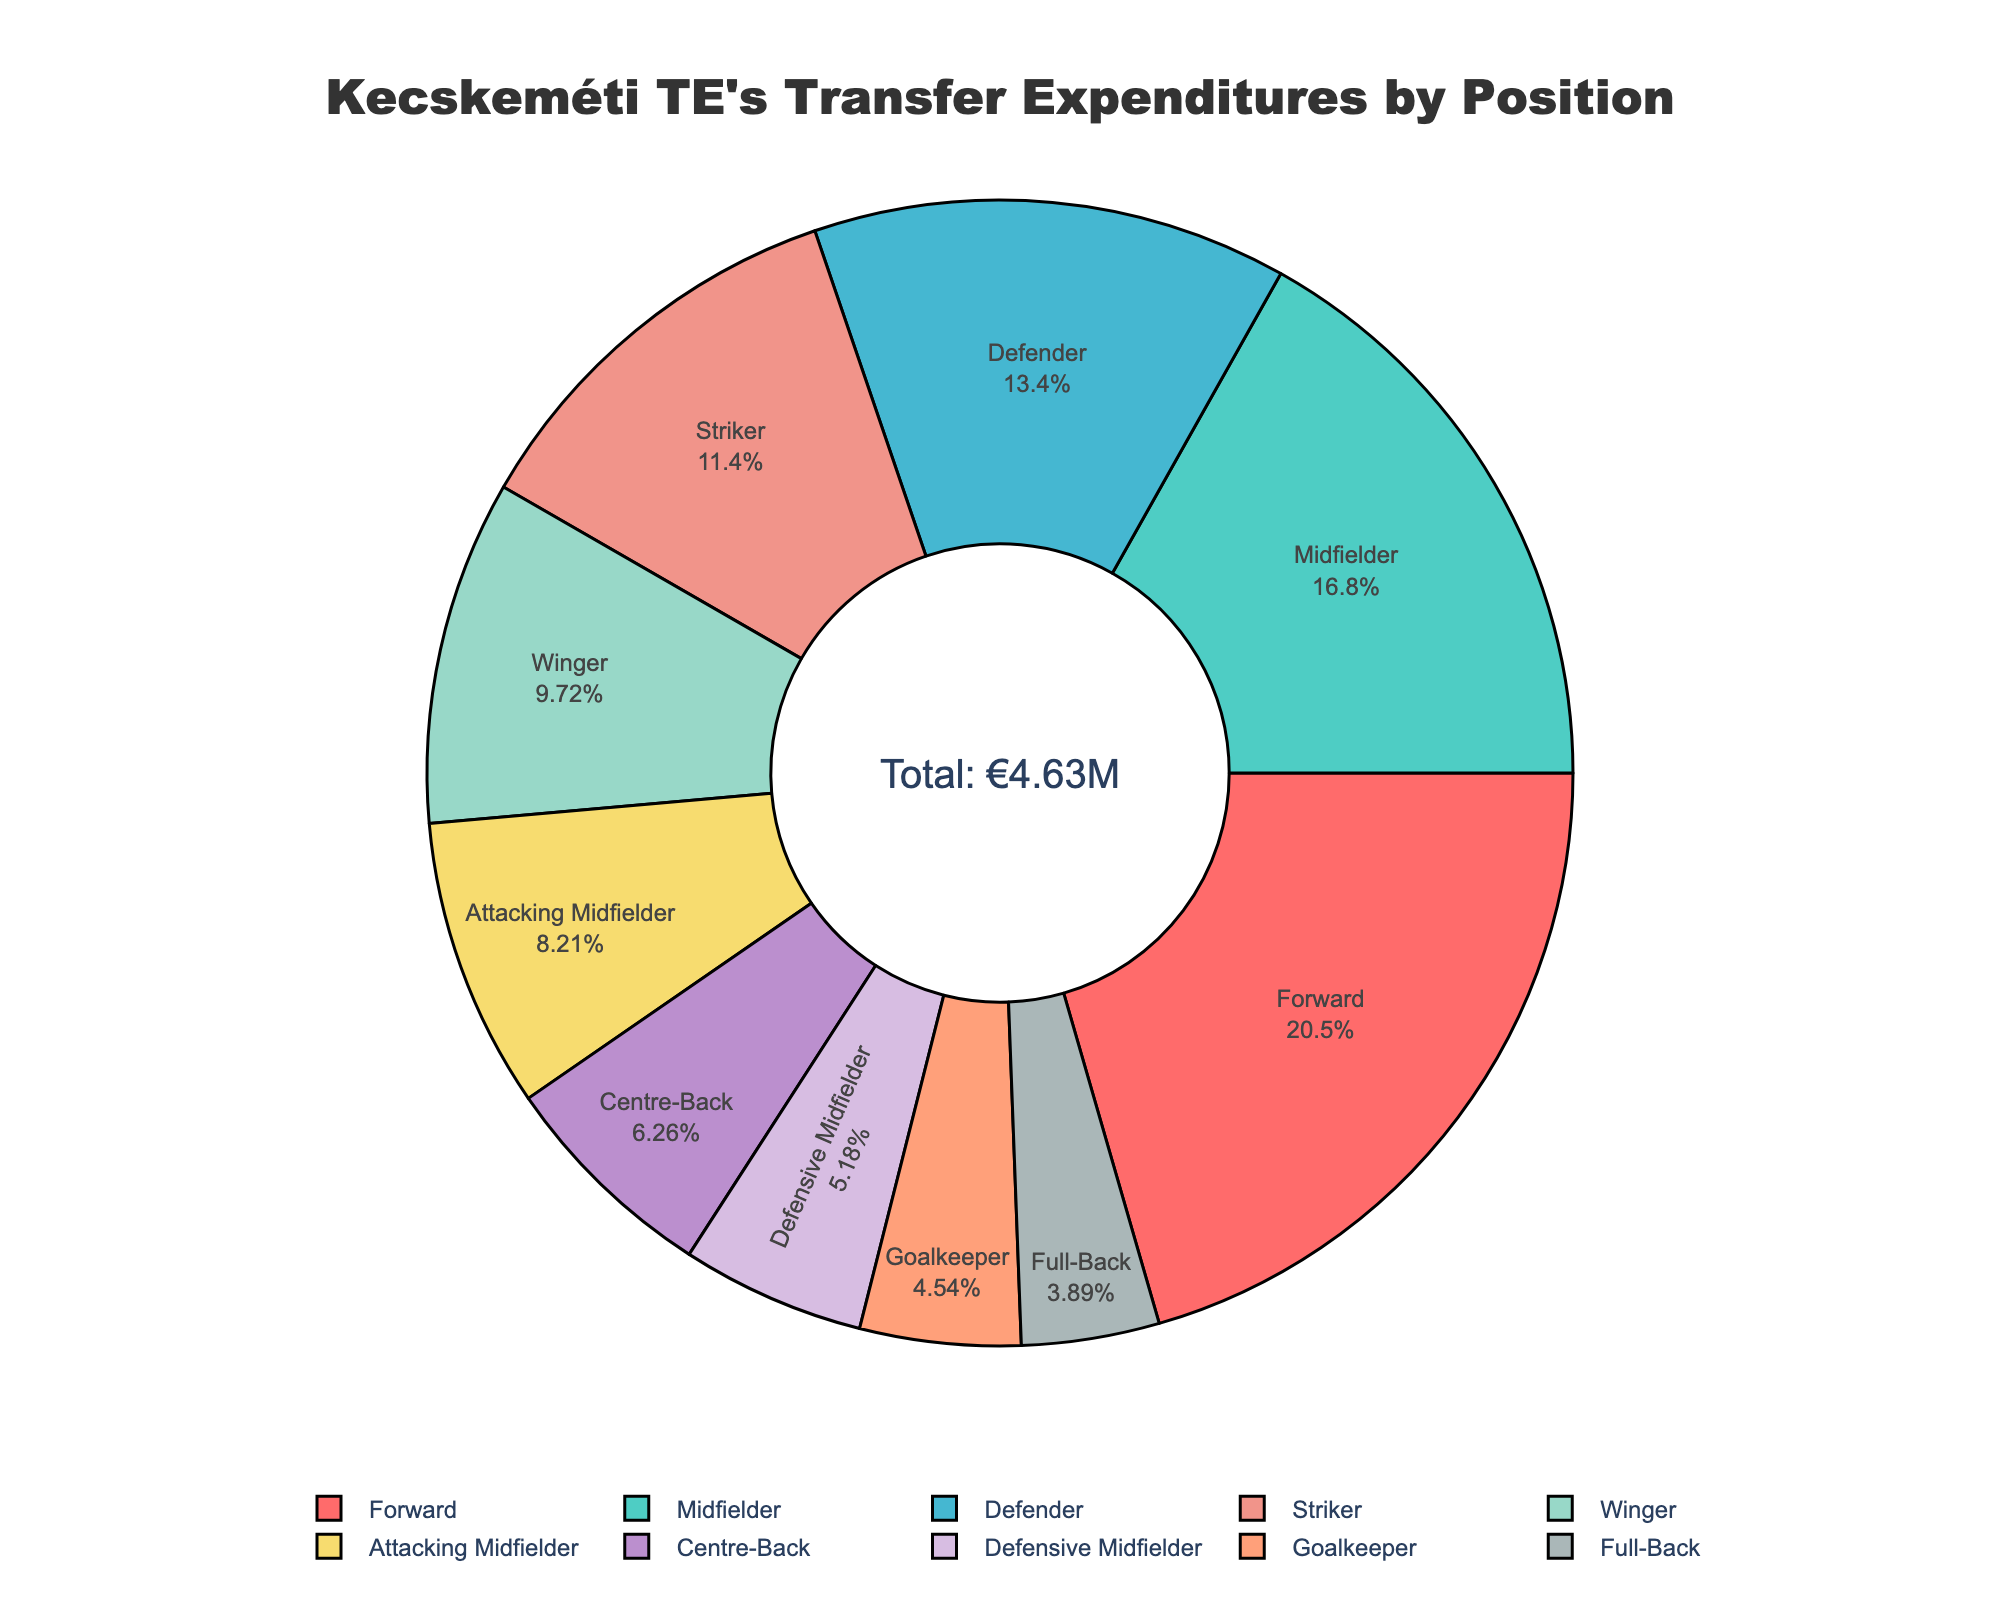What's the largest percentage of transfer expenditures for a single position? By looking at the pie chart, identify the segment with the largest percentage indicating a single position's transfer expenditure share.
Answer: Forward with 20.52% Which position has the smallest transfer expenditures in the last five years? Identify the smallest segment from the pie chart, indicating the least transfer expenditure.
Answer: Full-Back Compare the transfer expenditures between Forward and Midfielder. Which one is higher? Compare the sizes or percentages of the segments labeled "Forward" and "Midfielder". Forward’s expenditure should be larger.
Answer: Forward What is the combined percentage of the transfer expenditures for Defender and Centre-Back? Sum the percentages of the segments labeled "Defender" and "Centre-Back".
Answer: 13.90% What is the difference in transfer expenditures between Striker and Attacking Midfielder? Use the hover info to get the values for Striker (530,000 EUR) and Attacking Midfielder (380,000 EUR), then subtract the smaller value from the larger one.
Answer: €150,000 What's the total percentage of transfer expenditures for players in defensive positions (Defender, Centre-Back, Defensive Midfielder, and Goalkeeper)? Add the percentages of the segments labeled Defender, Centre-Back, Defensive Midfielder, and Goalkeeper.
Answer: 30.11% Which two positions have the closest transfer expenditures in percentages? Look for the two segments whose percentages are the closest to each other. This can be Winger (9.72%) and Attacking Midfielder (8.21%).
Answer: Winger and Attacking Midfielder What is the combined expenditure for Winger and Defensive Midfielder? Use the hover info to get the values for Winger (450,000 EUR) and Defensive Midfielder (240,000 EUR), then add them together.
Answer: €690,000 Identify the segment with the lightest shade of blue. Which position does it represent? By looking at the color coding, spot the segment colored with the lightest shade of blue.
Answer: Centre-Back What percentage of the total transfer expenditures does the goalkeeper position account for? Look for the segment labeled "Goalkeeper" and note its percentage.
Answer: 4.54% 